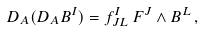<formula> <loc_0><loc_0><loc_500><loc_500>D _ { A } ( D _ { A } B ^ { I } ) = f ^ { I } _ { J L } \, F ^ { J } \wedge B ^ { L } \, ,</formula> 